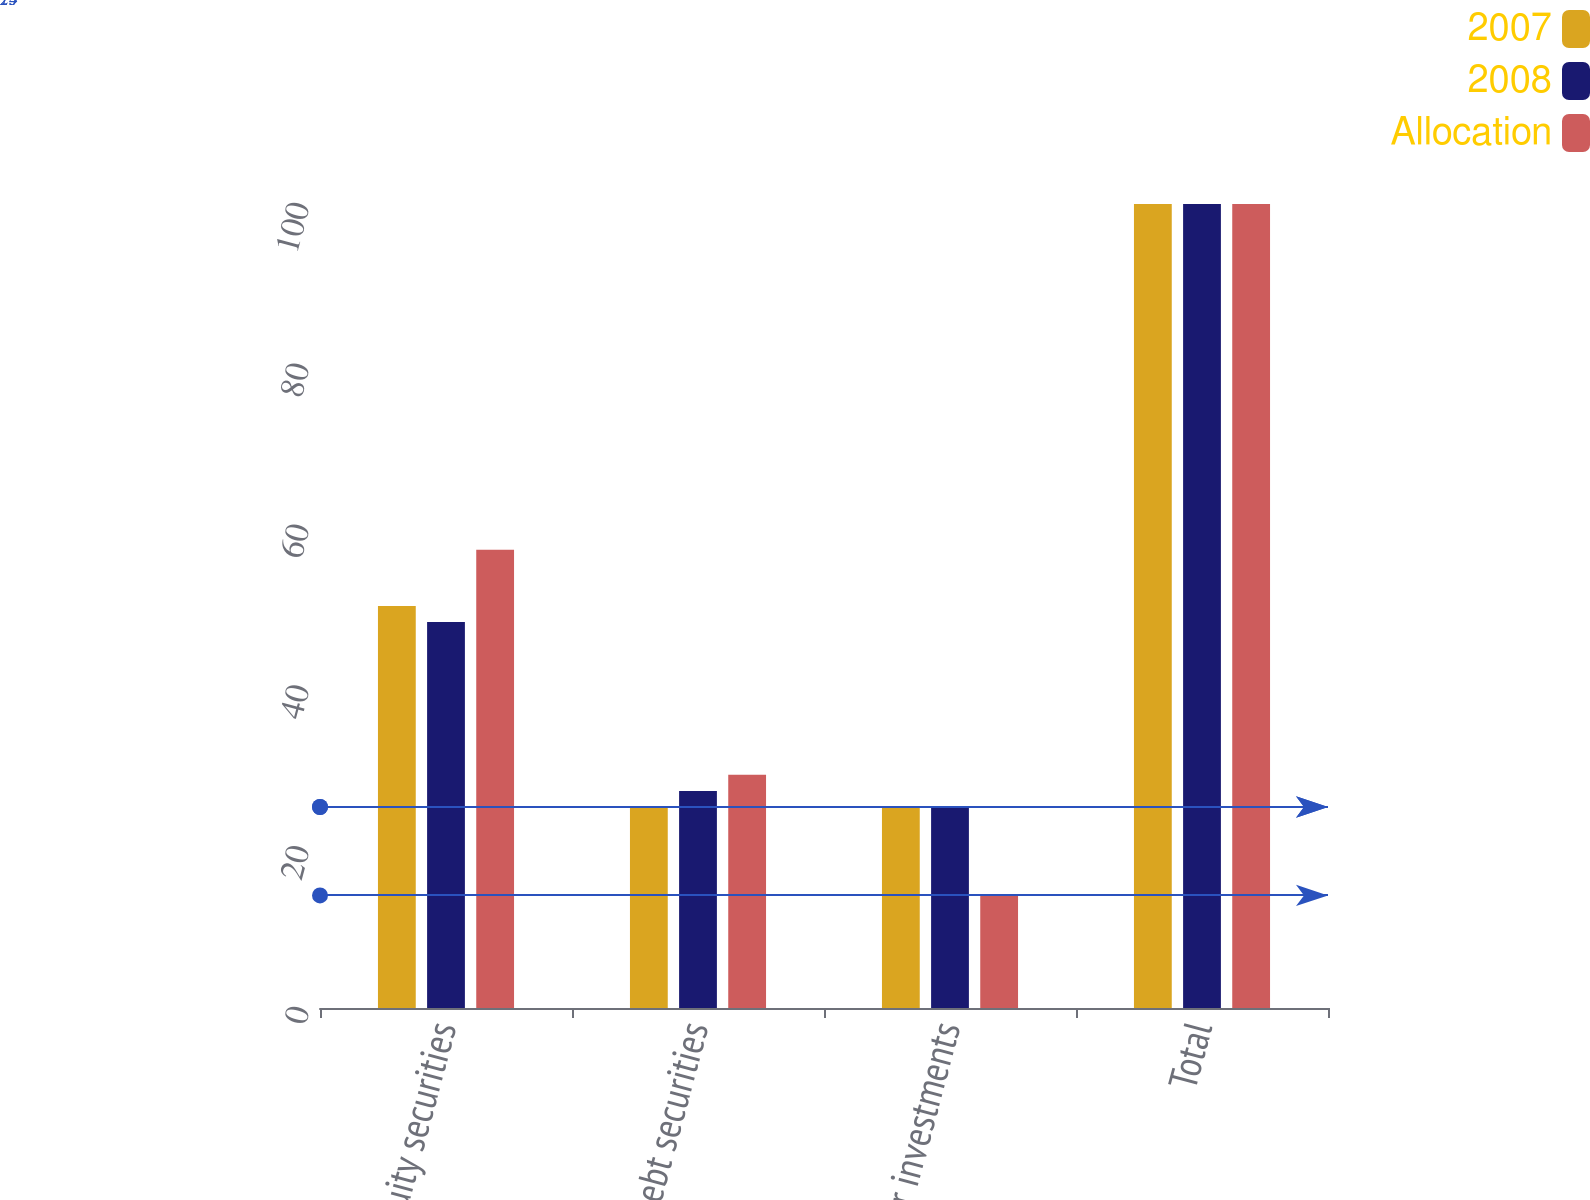Convert chart to OTSL. <chart><loc_0><loc_0><loc_500><loc_500><stacked_bar_chart><ecel><fcel>Equity securities<fcel>Debt securities<fcel>Other investments<fcel>Total<nl><fcel>2007<fcel>50<fcel>25<fcel>25<fcel>100<nl><fcel>2008<fcel>48<fcel>27<fcel>25<fcel>100<nl><fcel>Allocation<fcel>57<fcel>29<fcel>14<fcel>100<nl></chart> 